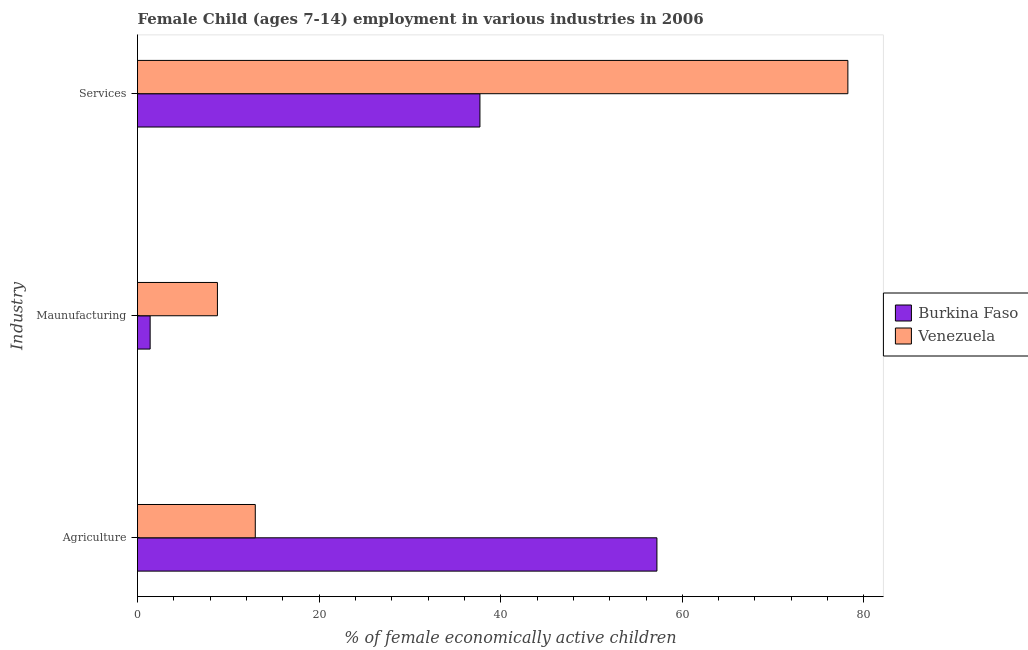How many groups of bars are there?
Keep it short and to the point. 3. Are the number of bars per tick equal to the number of legend labels?
Give a very brief answer. Yes. How many bars are there on the 2nd tick from the top?
Provide a succinct answer. 2. What is the label of the 3rd group of bars from the top?
Offer a terse response. Agriculture. What is the percentage of economically active children in agriculture in Venezuela?
Offer a terse response. 12.97. Across all countries, what is the maximum percentage of economically active children in services?
Ensure brevity in your answer.  78.23. Across all countries, what is the minimum percentage of economically active children in services?
Make the answer very short. 37.71. In which country was the percentage of economically active children in agriculture maximum?
Ensure brevity in your answer.  Burkina Faso. In which country was the percentage of economically active children in agriculture minimum?
Offer a very short reply. Venezuela. What is the total percentage of economically active children in agriculture in the graph?
Your response must be concise. 70.17. What is the difference between the percentage of economically active children in agriculture in Burkina Faso and that in Venezuela?
Make the answer very short. 44.23. What is the difference between the percentage of economically active children in agriculture in Venezuela and the percentage of economically active children in manufacturing in Burkina Faso?
Make the answer very short. 11.58. What is the average percentage of economically active children in agriculture per country?
Keep it short and to the point. 35.09. What is the difference between the percentage of economically active children in services and percentage of economically active children in manufacturing in Venezuela?
Provide a short and direct response. 69.43. What is the ratio of the percentage of economically active children in manufacturing in Venezuela to that in Burkina Faso?
Offer a very short reply. 6.33. Is the percentage of economically active children in services in Burkina Faso less than that in Venezuela?
Provide a short and direct response. Yes. Is the difference between the percentage of economically active children in agriculture in Venezuela and Burkina Faso greater than the difference between the percentage of economically active children in services in Venezuela and Burkina Faso?
Keep it short and to the point. No. What is the difference between the highest and the second highest percentage of economically active children in manufacturing?
Ensure brevity in your answer.  7.41. What is the difference between the highest and the lowest percentage of economically active children in agriculture?
Make the answer very short. 44.23. What does the 1st bar from the top in Maunufacturing represents?
Give a very brief answer. Venezuela. What does the 1st bar from the bottom in Services represents?
Make the answer very short. Burkina Faso. How many bars are there?
Your answer should be compact. 6. Are all the bars in the graph horizontal?
Offer a terse response. Yes. What is the difference between two consecutive major ticks on the X-axis?
Your answer should be very brief. 20. Does the graph contain any zero values?
Your answer should be very brief. No. Does the graph contain grids?
Offer a terse response. No. How many legend labels are there?
Offer a very short reply. 2. What is the title of the graph?
Your answer should be very brief. Female Child (ages 7-14) employment in various industries in 2006. What is the label or title of the X-axis?
Your response must be concise. % of female economically active children. What is the label or title of the Y-axis?
Provide a succinct answer. Industry. What is the % of female economically active children of Burkina Faso in Agriculture?
Your response must be concise. 57.2. What is the % of female economically active children of Venezuela in Agriculture?
Your answer should be compact. 12.97. What is the % of female economically active children in Burkina Faso in Maunufacturing?
Keep it short and to the point. 1.39. What is the % of female economically active children in Venezuela in Maunufacturing?
Ensure brevity in your answer.  8.8. What is the % of female economically active children of Burkina Faso in Services?
Keep it short and to the point. 37.71. What is the % of female economically active children in Venezuela in Services?
Ensure brevity in your answer.  78.23. Across all Industry, what is the maximum % of female economically active children in Burkina Faso?
Your response must be concise. 57.2. Across all Industry, what is the maximum % of female economically active children in Venezuela?
Give a very brief answer. 78.23. Across all Industry, what is the minimum % of female economically active children of Burkina Faso?
Make the answer very short. 1.39. Across all Industry, what is the minimum % of female economically active children of Venezuela?
Give a very brief answer. 8.8. What is the total % of female economically active children in Burkina Faso in the graph?
Offer a very short reply. 96.3. What is the difference between the % of female economically active children in Burkina Faso in Agriculture and that in Maunufacturing?
Make the answer very short. 55.81. What is the difference between the % of female economically active children in Venezuela in Agriculture and that in Maunufacturing?
Your answer should be very brief. 4.17. What is the difference between the % of female economically active children in Burkina Faso in Agriculture and that in Services?
Make the answer very short. 19.49. What is the difference between the % of female economically active children in Venezuela in Agriculture and that in Services?
Provide a succinct answer. -65.26. What is the difference between the % of female economically active children in Burkina Faso in Maunufacturing and that in Services?
Offer a terse response. -36.32. What is the difference between the % of female economically active children of Venezuela in Maunufacturing and that in Services?
Provide a succinct answer. -69.43. What is the difference between the % of female economically active children in Burkina Faso in Agriculture and the % of female economically active children in Venezuela in Maunufacturing?
Ensure brevity in your answer.  48.4. What is the difference between the % of female economically active children of Burkina Faso in Agriculture and the % of female economically active children of Venezuela in Services?
Ensure brevity in your answer.  -21.03. What is the difference between the % of female economically active children of Burkina Faso in Maunufacturing and the % of female economically active children of Venezuela in Services?
Offer a very short reply. -76.84. What is the average % of female economically active children in Burkina Faso per Industry?
Your answer should be compact. 32.1. What is the average % of female economically active children of Venezuela per Industry?
Provide a short and direct response. 33.33. What is the difference between the % of female economically active children of Burkina Faso and % of female economically active children of Venezuela in Agriculture?
Provide a short and direct response. 44.23. What is the difference between the % of female economically active children in Burkina Faso and % of female economically active children in Venezuela in Maunufacturing?
Offer a very short reply. -7.41. What is the difference between the % of female economically active children in Burkina Faso and % of female economically active children in Venezuela in Services?
Give a very brief answer. -40.52. What is the ratio of the % of female economically active children in Burkina Faso in Agriculture to that in Maunufacturing?
Your answer should be very brief. 41.15. What is the ratio of the % of female economically active children of Venezuela in Agriculture to that in Maunufacturing?
Your answer should be very brief. 1.47. What is the ratio of the % of female economically active children in Burkina Faso in Agriculture to that in Services?
Provide a succinct answer. 1.52. What is the ratio of the % of female economically active children in Venezuela in Agriculture to that in Services?
Your answer should be very brief. 0.17. What is the ratio of the % of female economically active children in Burkina Faso in Maunufacturing to that in Services?
Give a very brief answer. 0.04. What is the ratio of the % of female economically active children of Venezuela in Maunufacturing to that in Services?
Your answer should be compact. 0.11. What is the difference between the highest and the second highest % of female economically active children in Burkina Faso?
Offer a terse response. 19.49. What is the difference between the highest and the second highest % of female economically active children in Venezuela?
Offer a terse response. 65.26. What is the difference between the highest and the lowest % of female economically active children in Burkina Faso?
Ensure brevity in your answer.  55.81. What is the difference between the highest and the lowest % of female economically active children in Venezuela?
Offer a terse response. 69.43. 